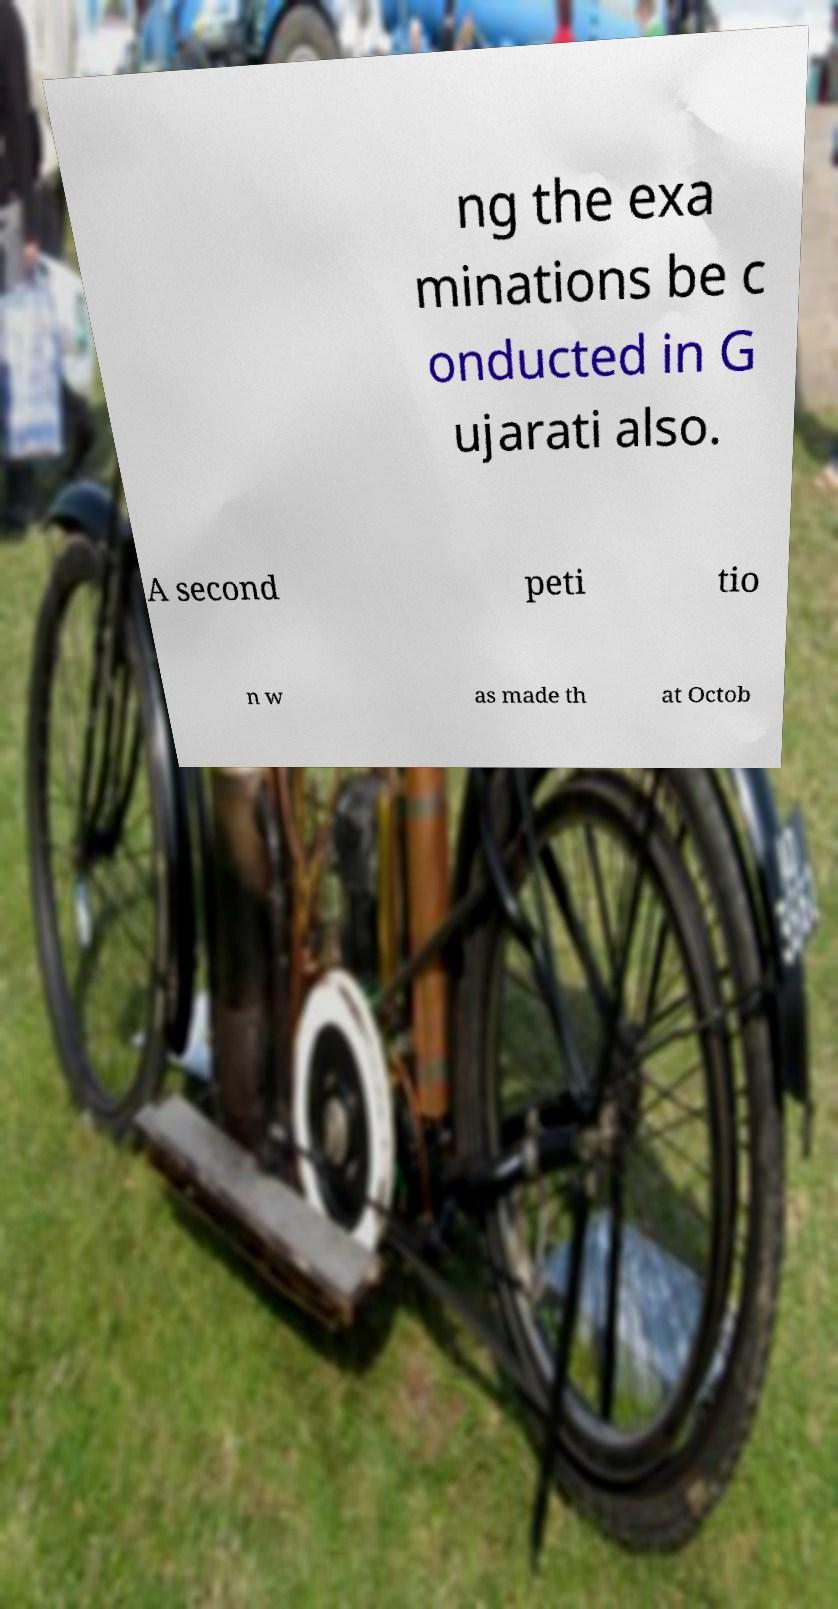I need the written content from this picture converted into text. Can you do that? ng the exa minations be c onducted in G ujarati also. A second peti tio n w as made th at Octob 